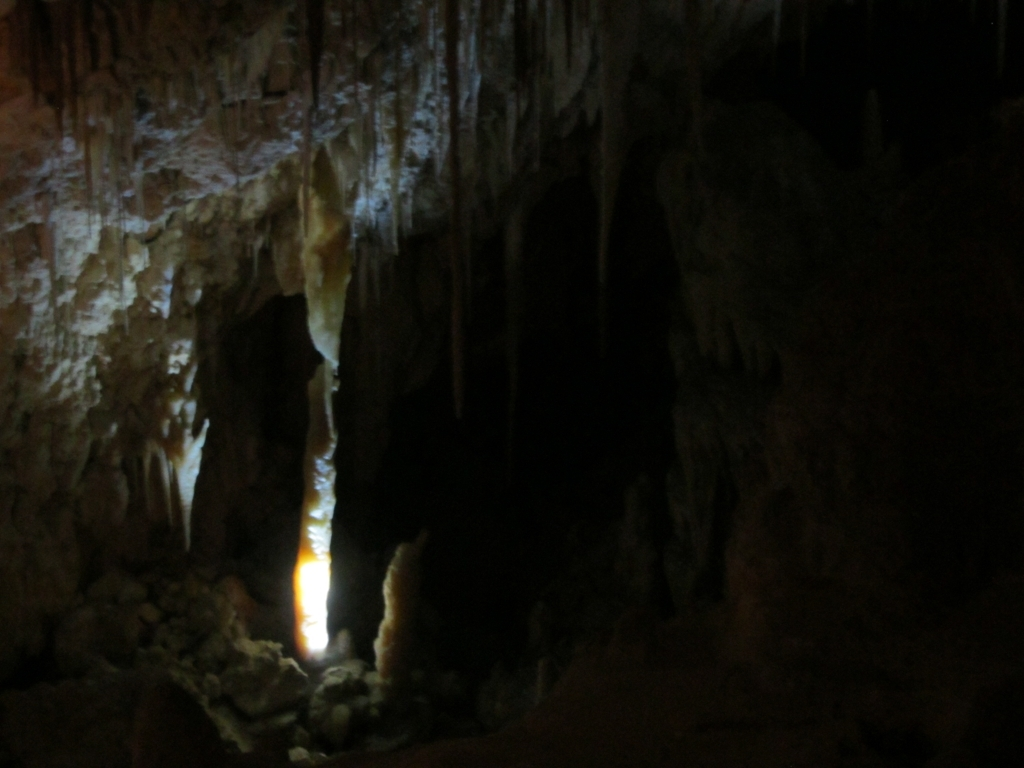Can you describe the environment where this picture was taken? The photograph appears to have been taken inside a cave. The darkness and the dramatic stalactites hanging from the ceiling suggest it might be a natural cavern. The source of light that is visible creates a spotlight effect, emphasizing specific formations and heightening the sense of mystery and awe typically associated with such underground landscapes. What kind of formations are the prominent features in this cave? The prominent features in this cave are the stalactites, which are the icicle-shaped formations hanging from the ceiling, and possibly stalagmites if those are present on the ground, though they are less visible due to the limited lighting. These formations are created by the deposition of minerals from dripping water over a considerable period and are common in limestone caves. 